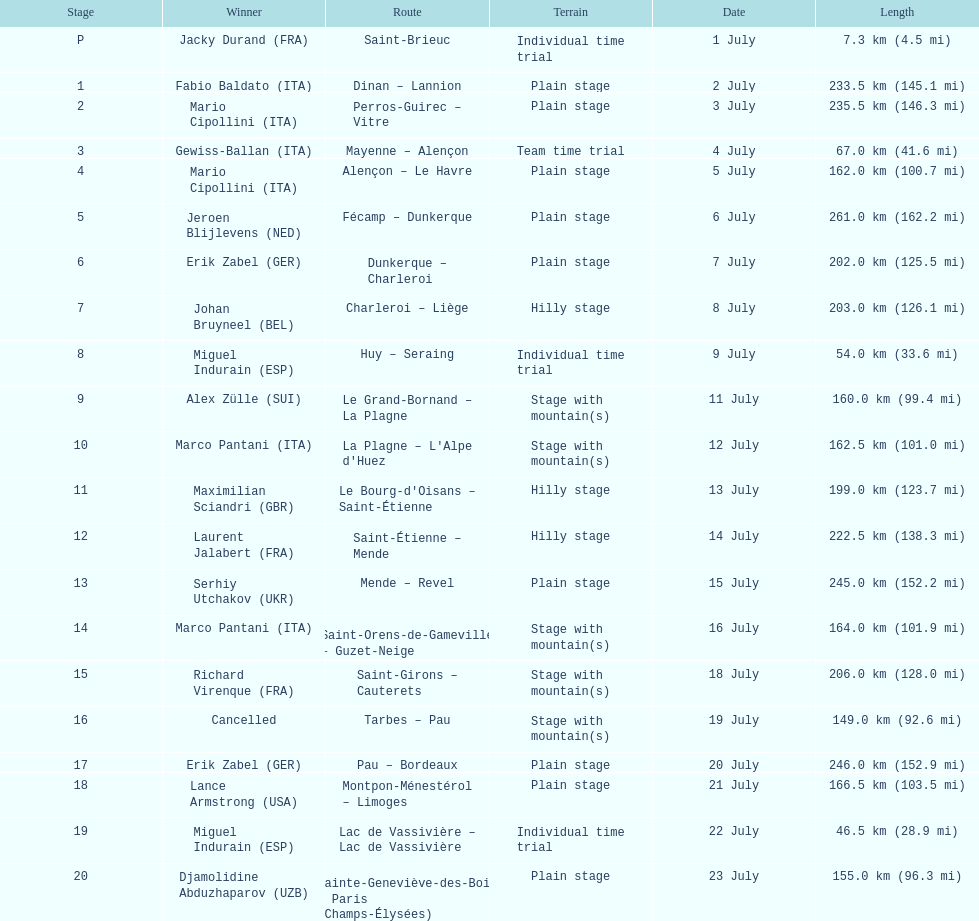How many stages were at least 200 km in length in the 1995 tour de france? 9. 